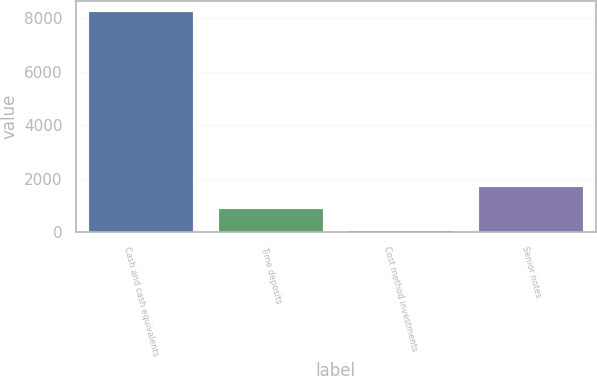Convert chart to OTSL. <chart><loc_0><loc_0><loc_500><loc_500><bar_chart><fcel>Cash and cash equivalents<fcel>Time deposits<fcel>Cost method investments<fcel>Senior notes<nl><fcel>8247.1<fcel>869.71<fcel>50<fcel>1689.42<nl></chart> 